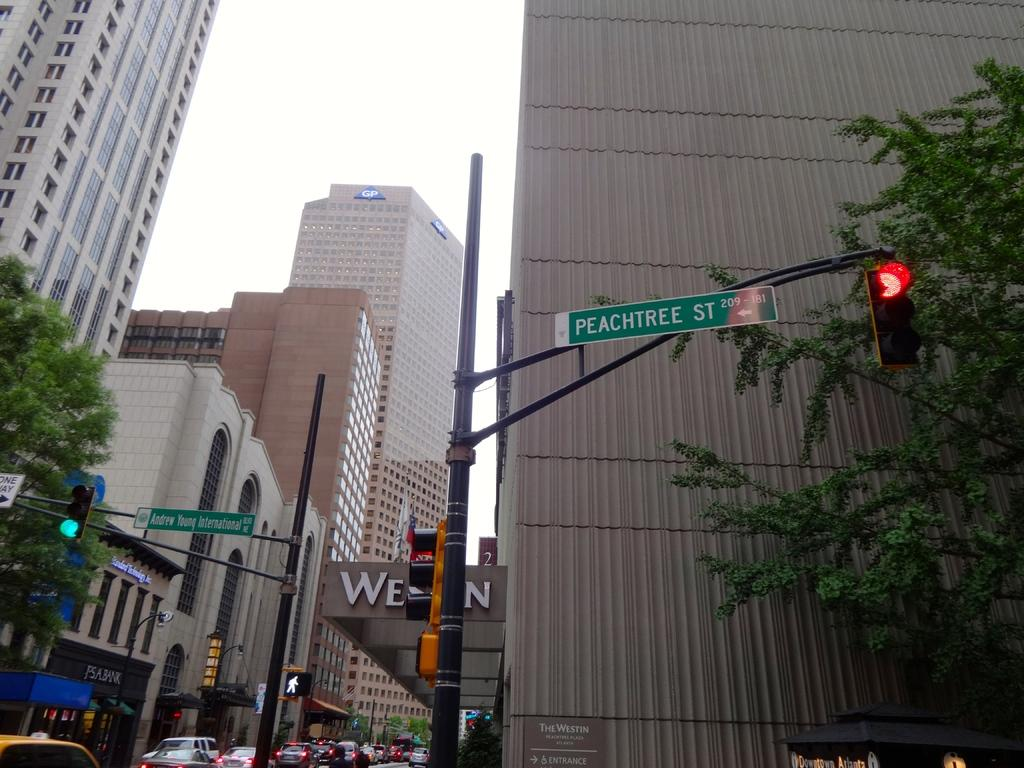<image>
Write a terse but informative summary of the picture. peachtree st is a sign that is above the road 